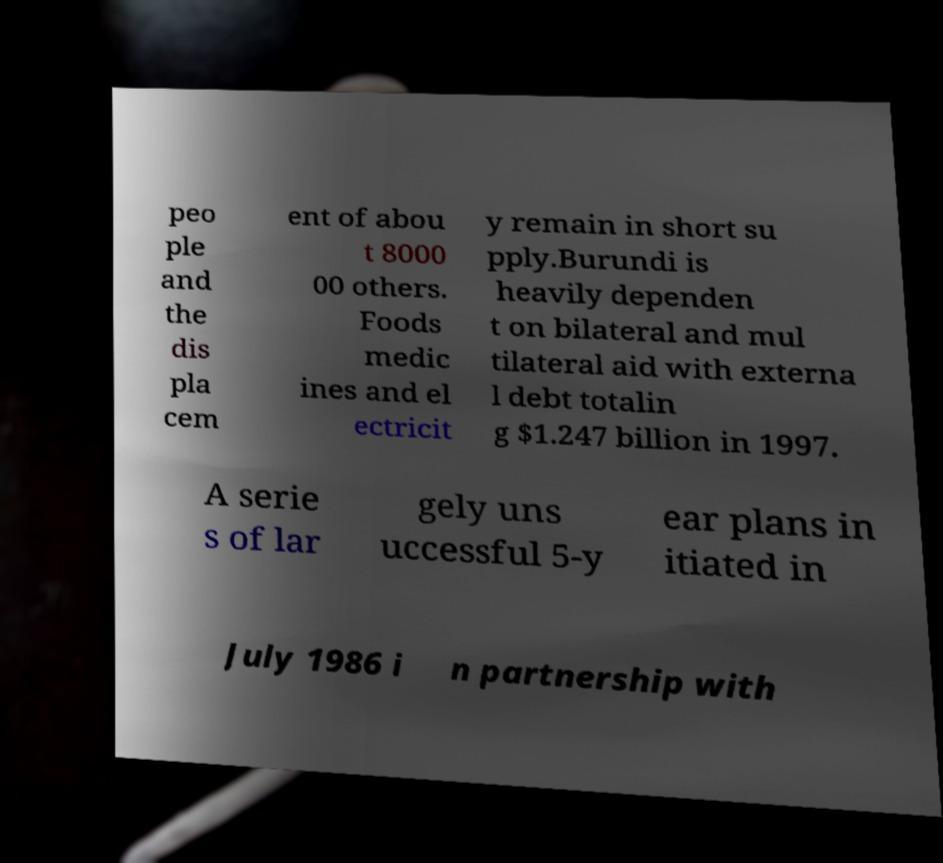Could you assist in decoding the text presented in this image and type it out clearly? peo ple and the dis pla cem ent of abou t 8000 00 others. Foods medic ines and el ectricit y remain in short su pply.Burundi is heavily dependen t on bilateral and mul tilateral aid with externa l debt totalin g $1.247 billion in 1997. A serie s of lar gely uns uccessful 5-y ear plans in itiated in July 1986 i n partnership with 